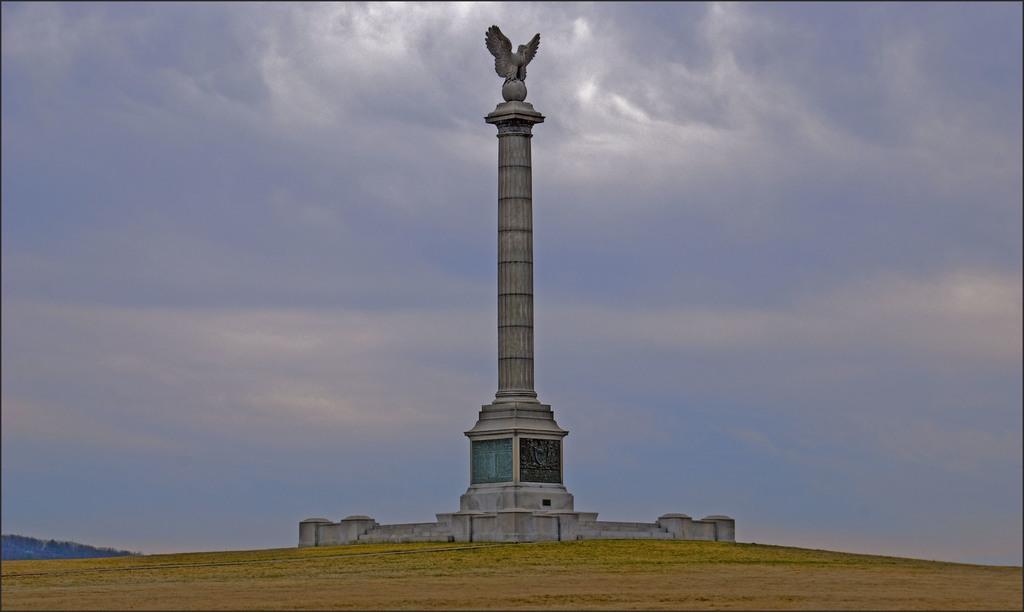Can you describe this image briefly? There is statue on a pillar in the center of the image, there is muddy texture at the bottom side of the image, it seems to be there are trees in the background and there is sky in the image. 